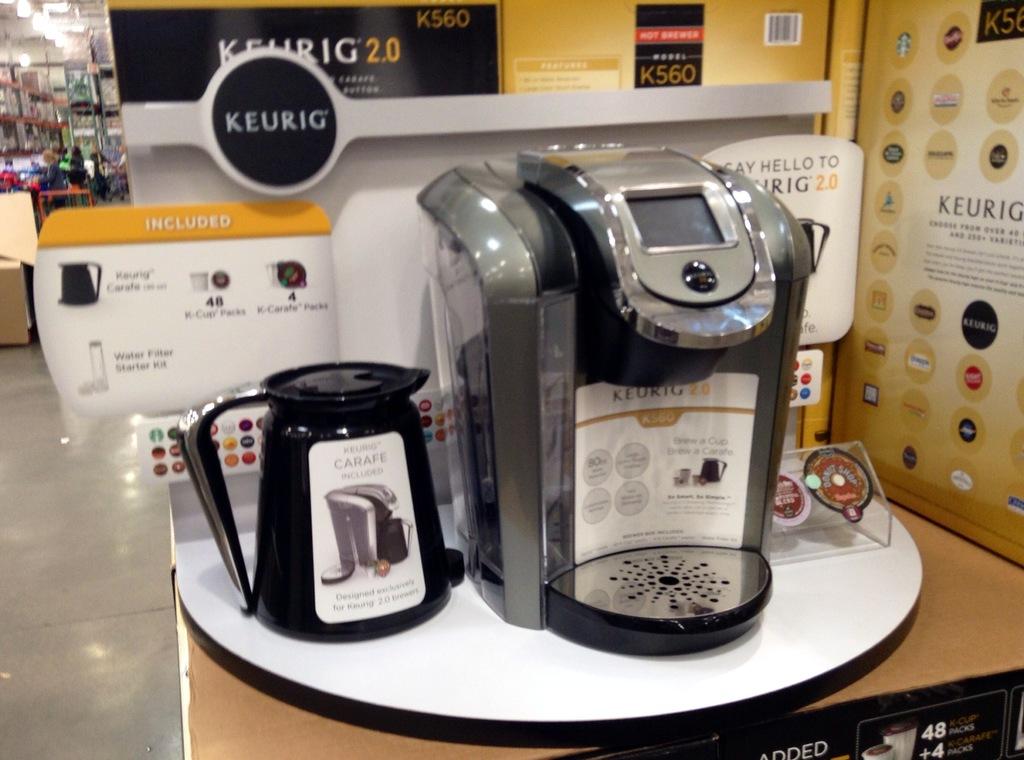What brand coffee maker is this?
Offer a very short reply. Keurig. 